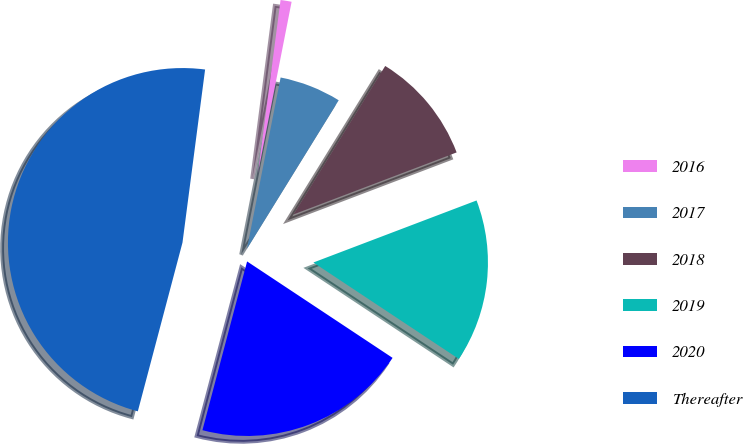<chart> <loc_0><loc_0><loc_500><loc_500><pie_chart><fcel>2016<fcel>2017<fcel>2018<fcel>2019<fcel>2020<fcel>Thereafter<nl><fcel>1.02%<fcel>5.72%<fcel>10.41%<fcel>15.1%<fcel>19.8%<fcel>47.95%<nl></chart> 